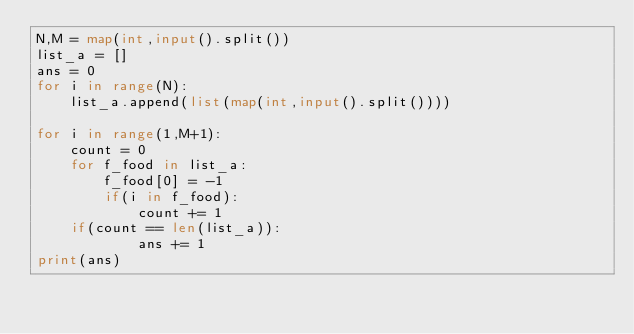Convert code to text. <code><loc_0><loc_0><loc_500><loc_500><_Python_>N,M = map(int,input().split())
list_a = []
ans = 0
for i in range(N):
    list_a.append(list(map(int,input().split())))

for i in range(1,M+1):
    count = 0
    for f_food in list_a:
        f_food[0] = -1
        if(i in f_food):
            count += 1
    if(count == len(list_a)):
            ans += 1
print(ans)
</code> 